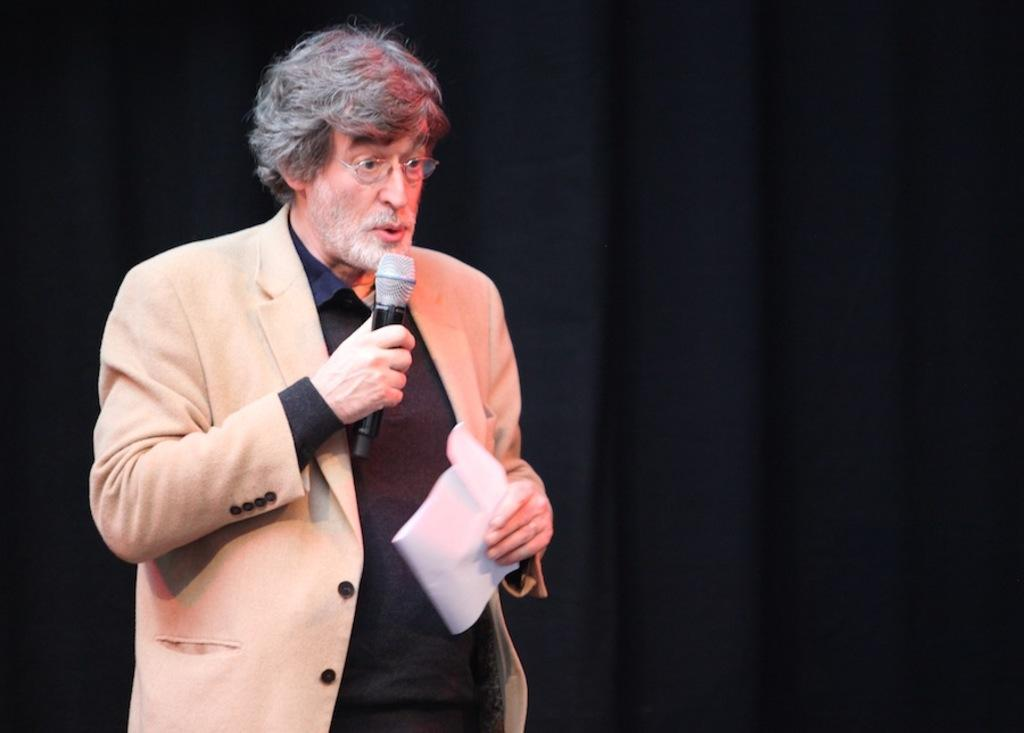Who is the main subject in the image? There is a man in the image. What is the man doing in the image? The man is standing in the image. What is the man holding in the image? The man is holding a mic in the image. What accessory is the man wearing in the image? The man is wearing glasses (specs) in the image. What type of clam is the man holding in the image? There is no clam present in the image; the man is holding a mic. What achievements has the goat in the image accomplished? There is no goat present in the image; the main subject is a man. 